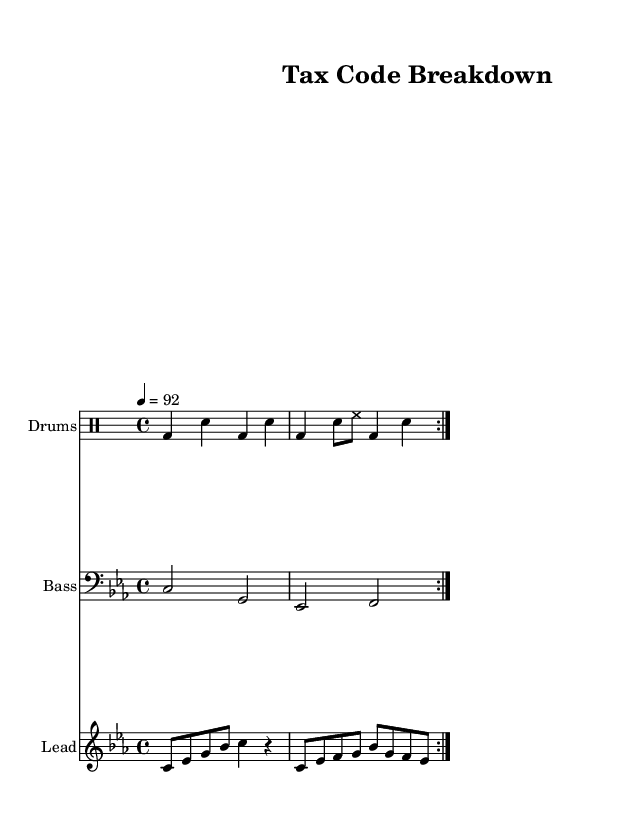What is the key signature of this music? The key signature indicated at the beginning is C minor, which is represented by three flats in the scale.
Answer: C minor What is the time signature of this piece? The time signature appears at the beginning of the score and is noted as 4/4, which means there are four beats per measure and a quarter note gets one beat.
Answer: 4/4 What is the tempo marking of the music? The tempo is written as 4 = 92, indicating that there are 92 quarter note beats in one minute, which defines the speed of the performance.
Answer: 92 What instrument accompanies the lead synth in the arrangement? The arrangement includes a drum staff that accompanies the lead synth, providing the rhythmic backbone for the rap piece.
Answer: Drums How many volta repeats are indicated in the drum beat? The score specifies a repeat of the drum beat twice, noted by "repeat volta 2" which directs the musician to play that section two times.
Answer: 2 What type of song structure is used in the lyrics? The lyrics display a typical structure for rap music, featuring verses followed by a chorus, showcasing the lyrical flow and thematic exploration of tax reforms.
Answer: Verse and chorus What is the main theme presented in the lyrics? The lyrics suggest a critique of the tax system using wordplay, reflecting a desire for reform and fairness in the tax code, which is a common theme in rap.
Answer: Tax reform 